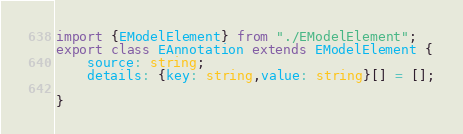Convert code to text. <code><loc_0><loc_0><loc_500><loc_500><_TypeScript_>import {EModelElement} from "./EModelElement";
export class EAnnotation extends EModelElement {
	source: string;
	details: {key: string,value: string}[] = [];

}
</code> 